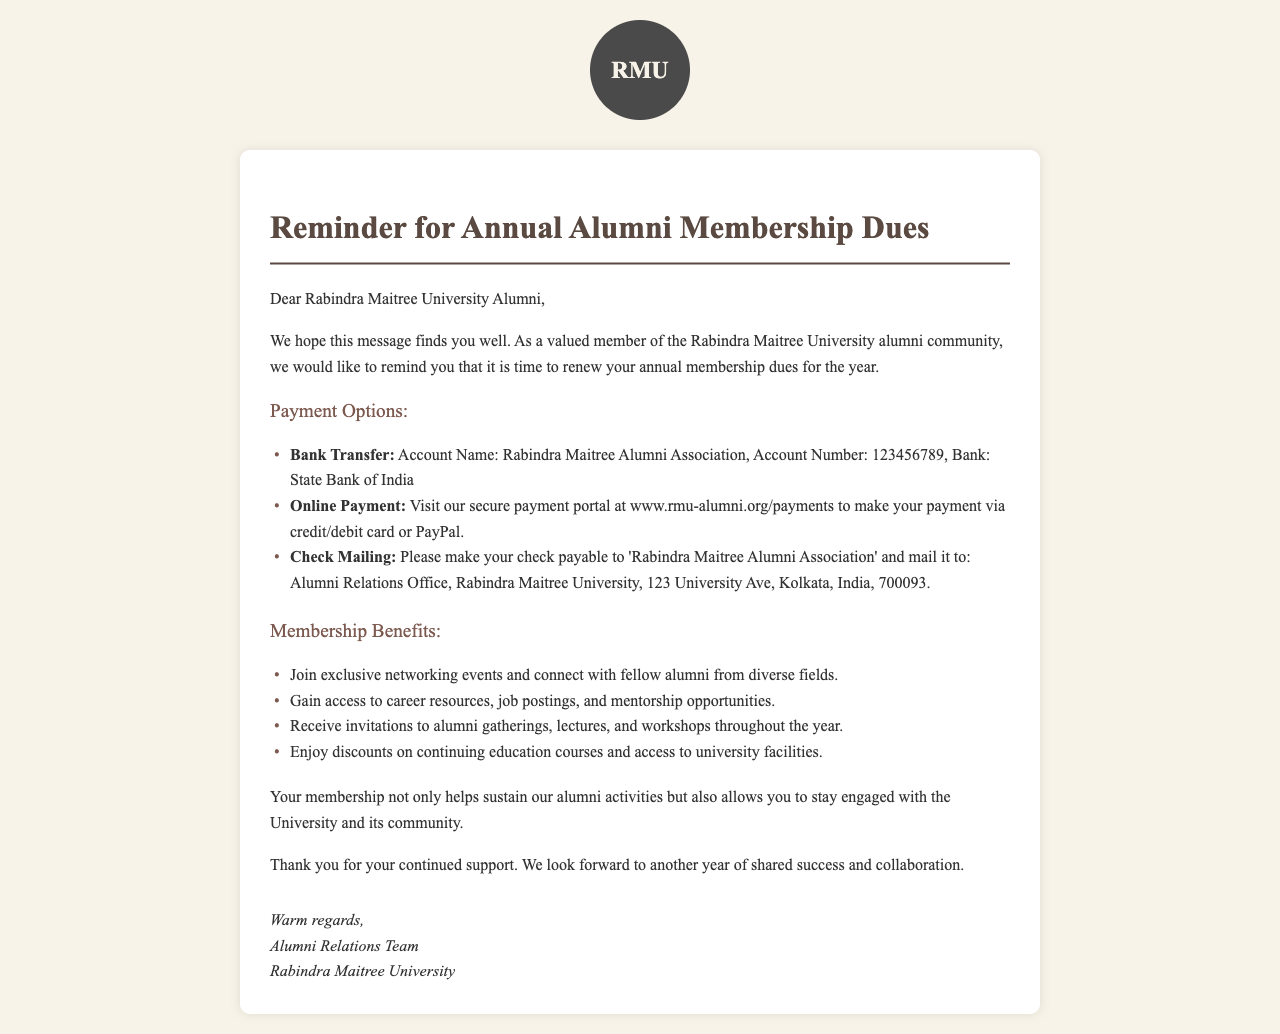What is the title of the document? The title is specified in the document's header and is meant to summarize the contents.
Answer: Reminder for Annual Alumni Membership Dues What is the account number for bank transfer? The account number is given under the payment options section for making payments through bank transfer.
Answer: 123456789 What website can alumni visit for online payment? The website is mentioned in the document for making payments via credit/debit card or PayPal.
Answer: www.rmu-alumni.org/payments What is one benefit of alumni membership? The document lists benefits of the membership, focusing on community engagement and access to resources.
Answer: Exclusive networking events Who is the letter addressed to? The salutation indicates the recipient of the letter, which designates the target audience.
Answer: Rabindra Maitree University Alumni What type of payment option requires mailing? The document describes different payment options available to alumni for dues payment.
Answer: Check Mailing How does the membership impact alumni activities? The document explains the role of membership dues in supporting community and university activities.
Answer: Sustain alumni activities What is the name listed on the checks for payment? The document specifies to whom the check should be made payable in the mailing payment option.
Answer: Rabindra Maitree Alumni Association 